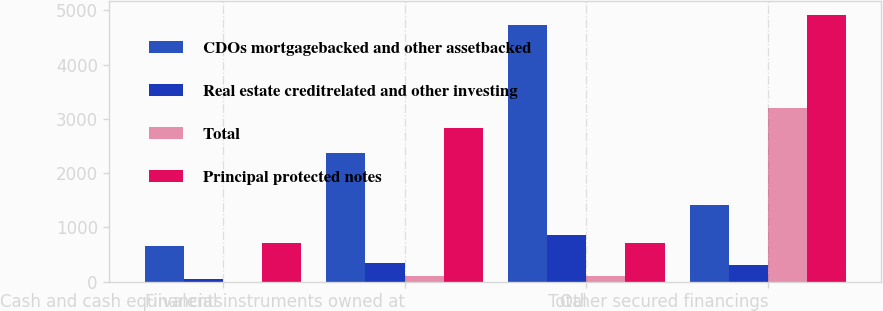Convert chart to OTSL. <chart><loc_0><loc_0><loc_500><loc_500><stacked_bar_chart><ecel><fcel>Cash and cash equivalents<fcel>Financial instruments owned at<fcel>Total<fcel>Other secured financings<nl><fcel>CDOs mortgagebacked and other assetbacked<fcel>660<fcel>2369<fcel>4724<fcel>1418<nl><fcel>Real estate creditrelated and other investing<fcel>51<fcel>352<fcel>856<fcel>298<nl><fcel>Total<fcel>1<fcel>112<fcel>113<fcel>3208<nl><fcel>Principal protected notes<fcel>712<fcel>2833<fcel>712<fcel>4924<nl></chart> 